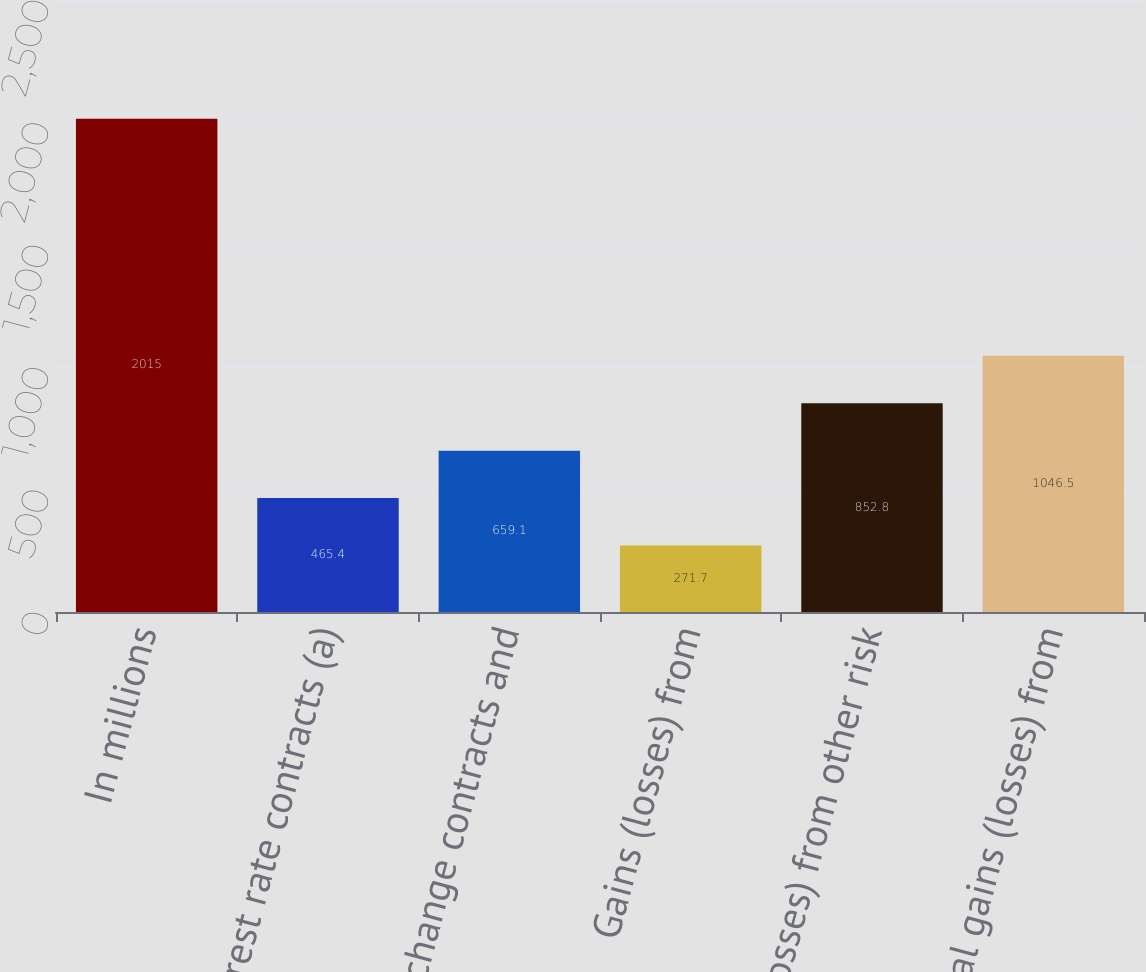Convert chart to OTSL. <chart><loc_0><loc_0><loc_500><loc_500><bar_chart><fcel>In millions<fcel>Interest rate contracts (a)<fcel>Foreign exchange contracts and<fcel>Gains (losses) from<fcel>Gains (losses) from other risk<fcel>Total gains (losses) from<nl><fcel>2015<fcel>465.4<fcel>659.1<fcel>271.7<fcel>852.8<fcel>1046.5<nl></chart> 